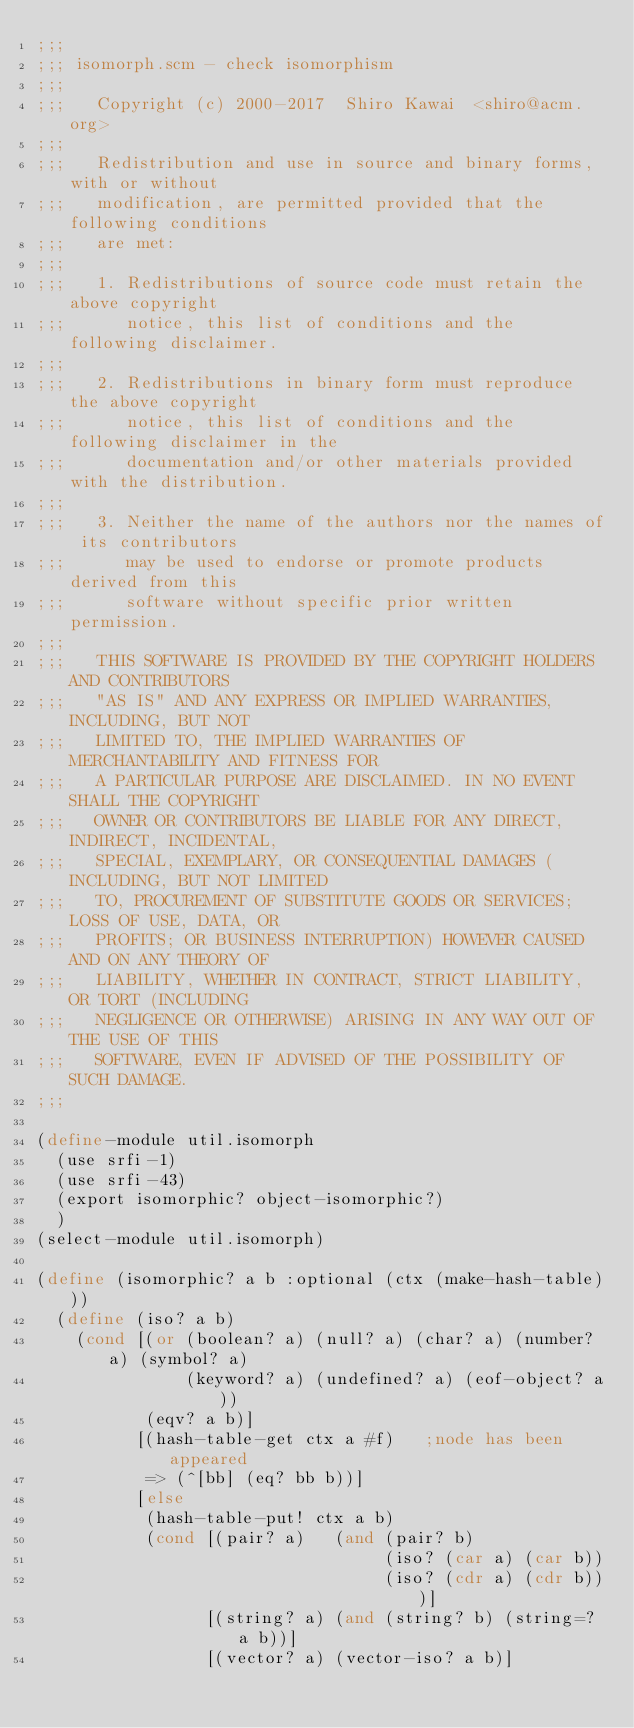<code> <loc_0><loc_0><loc_500><loc_500><_Scheme_>;;;
;;; isomorph.scm - check isomorphism
;;;
;;;   Copyright (c) 2000-2017  Shiro Kawai  <shiro@acm.org>
;;;
;;;   Redistribution and use in source and binary forms, with or without
;;;   modification, are permitted provided that the following conditions
;;;   are met:
;;;
;;;   1. Redistributions of source code must retain the above copyright
;;;      notice, this list of conditions and the following disclaimer.
;;;
;;;   2. Redistributions in binary form must reproduce the above copyright
;;;      notice, this list of conditions and the following disclaimer in the
;;;      documentation and/or other materials provided with the distribution.
;;;
;;;   3. Neither the name of the authors nor the names of its contributors
;;;      may be used to endorse or promote products derived from this
;;;      software without specific prior written permission.
;;;
;;;   THIS SOFTWARE IS PROVIDED BY THE COPYRIGHT HOLDERS AND CONTRIBUTORS
;;;   "AS IS" AND ANY EXPRESS OR IMPLIED WARRANTIES, INCLUDING, BUT NOT
;;;   LIMITED TO, THE IMPLIED WARRANTIES OF MERCHANTABILITY AND FITNESS FOR
;;;   A PARTICULAR PURPOSE ARE DISCLAIMED. IN NO EVENT SHALL THE COPYRIGHT
;;;   OWNER OR CONTRIBUTORS BE LIABLE FOR ANY DIRECT, INDIRECT, INCIDENTAL,
;;;   SPECIAL, EXEMPLARY, OR CONSEQUENTIAL DAMAGES (INCLUDING, BUT NOT LIMITED
;;;   TO, PROCUREMENT OF SUBSTITUTE GOODS OR SERVICES; LOSS OF USE, DATA, OR
;;;   PROFITS; OR BUSINESS INTERRUPTION) HOWEVER CAUSED AND ON ANY THEORY OF
;;;   LIABILITY, WHETHER IN CONTRACT, STRICT LIABILITY, OR TORT (INCLUDING
;;;   NEGLIGENCE OR OTHERWISE) ARISING IN ANY WAY OUT OF THE USE OF THIS
;;;   SOFTWARE, EVEN IF ADVISED OF THE POSSIBILITY OF SUCH DAMAGE.
;;;

(define-module util.isomorph
  (use srfi-1)
  (use srfi-43)
  (export isomorphic? object-isomorphic?)
  )
(select-module util.isomorph)

(define (isomorphic? a b :optional (ctx (make-hash-table)))
  (define (iso? a b)
    (cond [(or (boolean? a) (null? a) (char? a) (number? a) (symbol? a)
               (keyword? a) (undefined? a) (eof-object? a))
           (eqv? a b)]
          [(hash-table-get ctx a #f)   ;node has been appeared
           => (^[bb] (eq? bb b))]
          [else
           (hash-table-put! ctx a b)
           (cond [(pair? a)   (and (pair? b)
                                   (iso? (car a) (car b))
                                   (iso? (cdr a) (cdr b)))]
                 [(string? a) (and (string? b) (string=? a b))]
                 [(vector? a) (vector-iso? a b)]</code> 